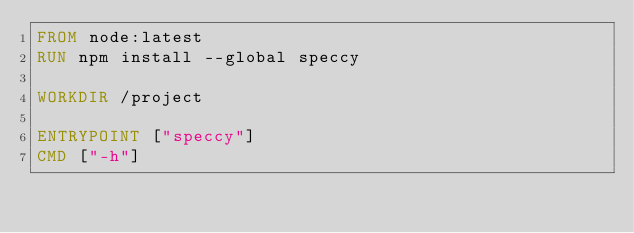Convert code to text. <code><loc_0><loc_0><loc_500><loc_500><_Dockerfile_>FROM node:latest
RUN npm install --global speccy

WORKDIR /project

ENTRYPOINT ["speccy"]
CMD ["-h"]</code> 